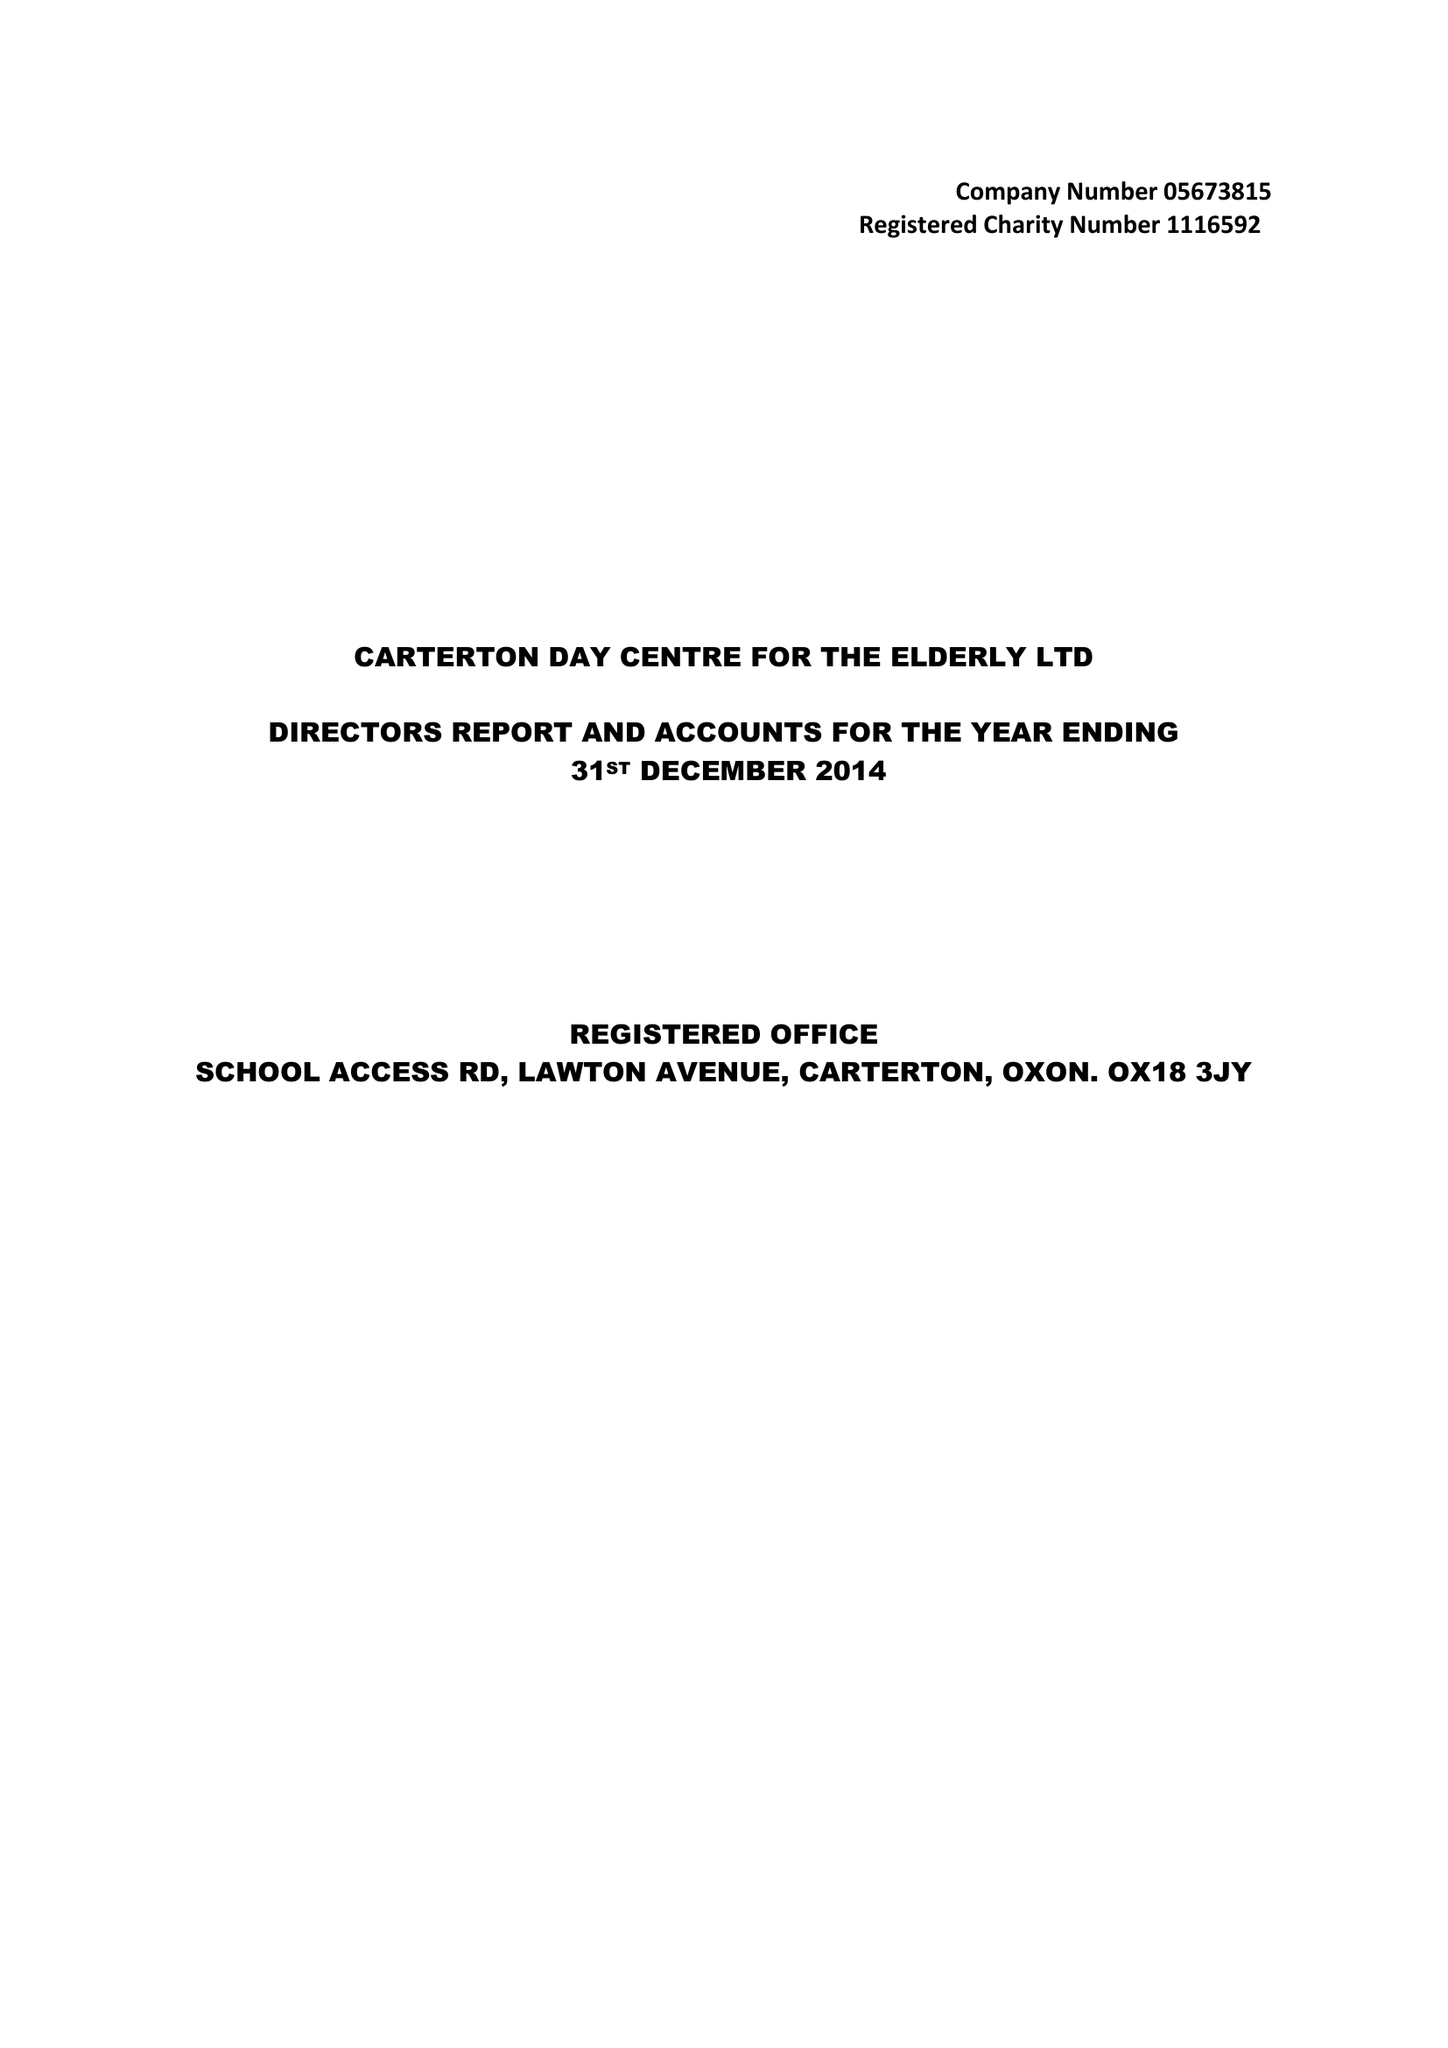What is the value for the income_annually_in_british_pounds?
Answer the question using a single word or phrase. 50772.00 